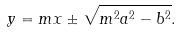<formula> <loc_0><loc_0><loc_500><loc_500>y = m x \pm { \sqrt { m ^ { 2 } a ^ { 2 } - b ^ { 2 } } } .</formula> 